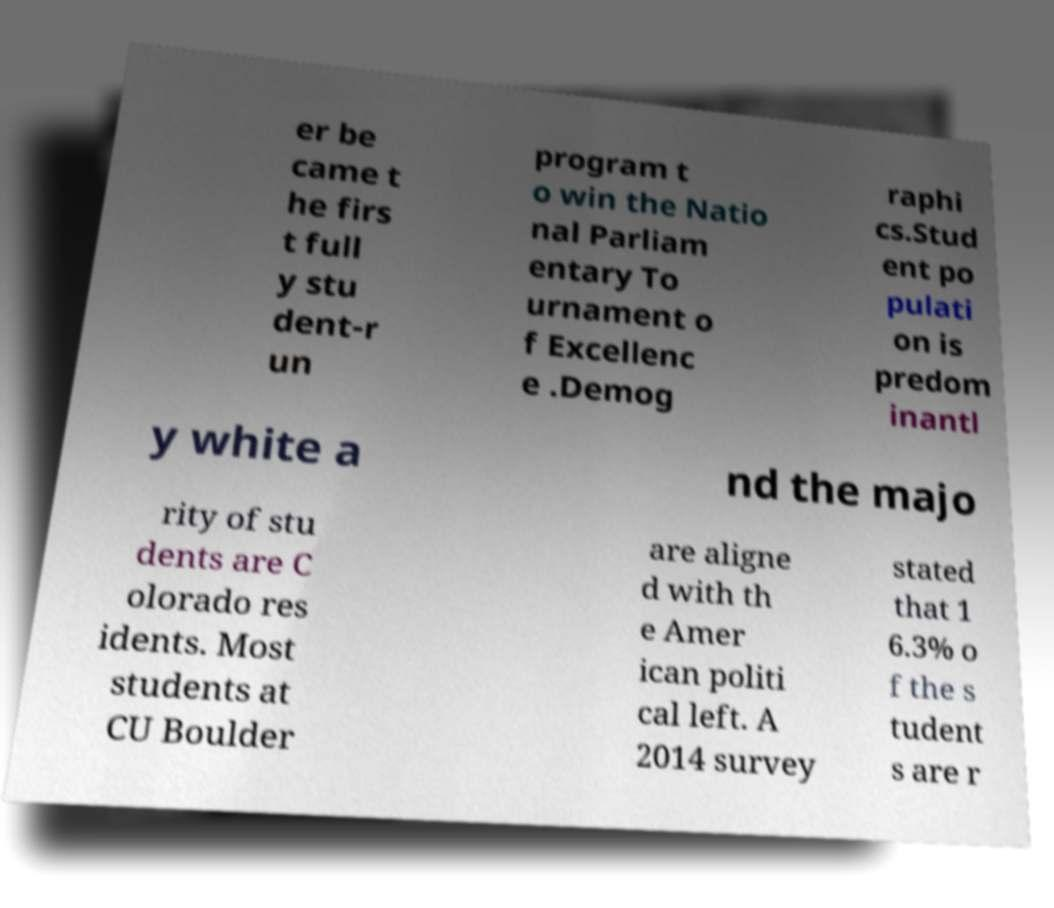Please read and relay the text visible in this image. What does it say? er be came t he firs t full y stu dent-r un program t o win the Natio nal Parliam entary To urnament o f Excellenc e .Demog raphi cs.Stud ent po pulati on is predom inantl y white a nd the majo rity of stu dents are C olorado res idents. Most students at CU Boulder are aligne d with th e Amer ican politi cal left. A 2014 survey stated that 1 6.3% o f the s tudent s are r 